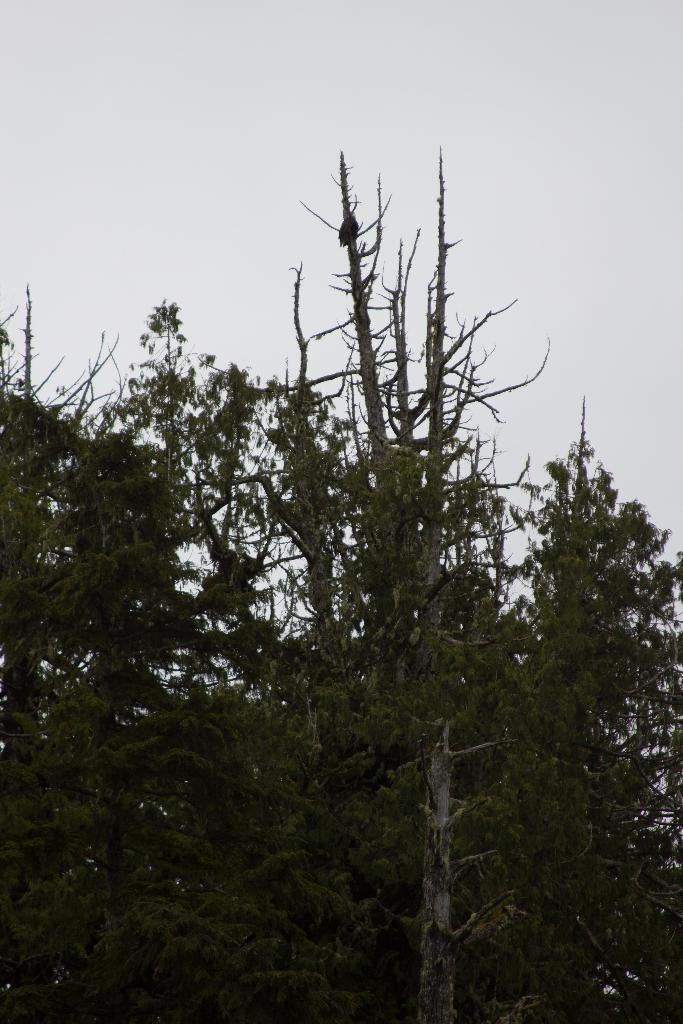Please provide a concise description of this image. In this picture I can see trees. In the background I can see the sky. 